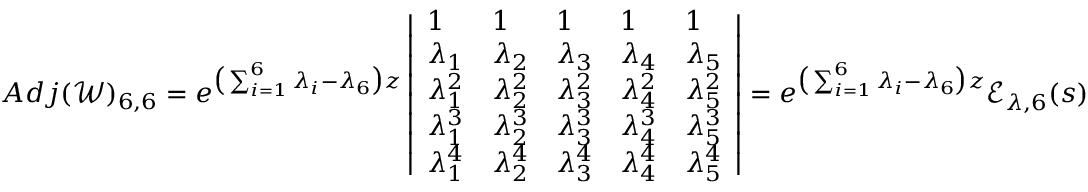<formula> <loc_0><loc_0><loc_500><loc_500>A d j ( \ m a t h s c r { W } ) _ { 6 , 6 } = e ^ { \left ( \sum _ { i = 1 } ^ { 6 } \lambda _ { i } - \lambda _ { 6 } \right ) z } \left | \begin{array} { l l l l l } { 1 } & { 1 } & { 1 } & { 1 } & { 1 } \\ { \lambda _ { 1 } } & { \lambda _ { 2 } } & { \lambda _ { 3 } } & { \lambda _ { 4 } } & { \lambda _ { 5 } } \\ { \lambda _ { 1 } ^ { 2 } } & { \lambda _ { 2 } ^ { 2 } } & { \lambda _ { 3 } ^ { 2 } } & { \lambda _ { 4 } ^ { 2 } } & { \lambda _ { 5 } ^ { 2 } } \\ { \lambda _ { 1 } ^ { 3 } } & { \lambda _ { 2 } ^ { 3 } } & { \lambda _ { 3 } ^ { 3 } } & { \lambda _ { 4 } ^ { 3 } } & { \lambda _ { 5 } ^ { 3 } } \\ { \lambda _ { 1 } ^ { 4 } } & { \lambda _ { 2 } ^ { 4 } } & { \lambda _ { 3 } ^ { 4 } } & { \lambda _ { 4 } ^ { 4 } } & { \lambda _ { 5 } ^ { 4 } } \end{array} \right | = e ^ { \left ( \sum _ { i = 1 } ^ { 6 } \lambda _ { i } - \lambda _ { 6 } \right ) z } \ m a t h s c r { E } _ { \lambda , 6 } ( s )</formula> 